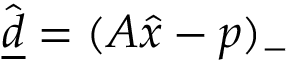<formula> <loc_0><loc_0><loc_500><loc_500>\hat { \underline { d } } = ( A \hat { x } - p ) _ { - }</formula> 